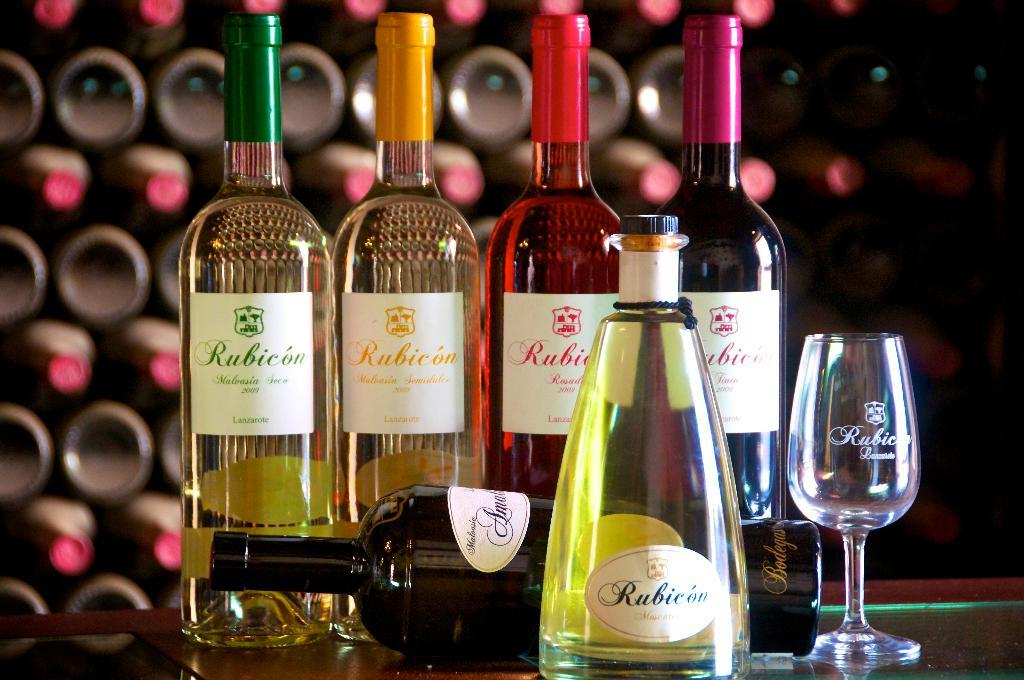<image>
Share a concise interpretation of the image provided. Several different colored bottles of wine from Rubicon are being displayed. 